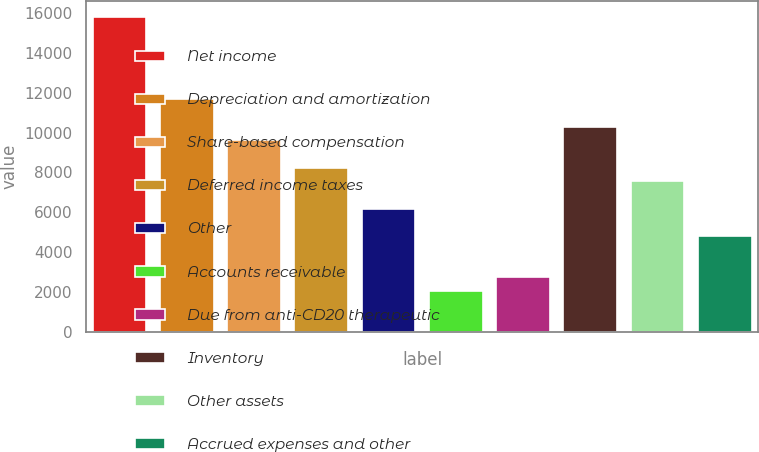Convert chart to OTSL. <chart><loc_0><loc_0><loc_500><loc_500><bar_chart><fcel>Net income<fcel>Depreciation and amortization<fcel>Share-based compensation<fcel>Deferred income taxes<fcel>Other<fcel>Accounts receivable<fcel>Due from anti-CD20 therapeutic<fcel>Inventory<fcel>Other assets<fcel>Accrued expenses and other<nl><fcel>15786.5<fcel>11668.9<fcel>9610.02<fcel>8237.46<fcel>6178.62<fcel>2060.94<fcel>2747.22<fcel>10296.3<fcel>7551.18<fcel>4806.06<nl></chart> 